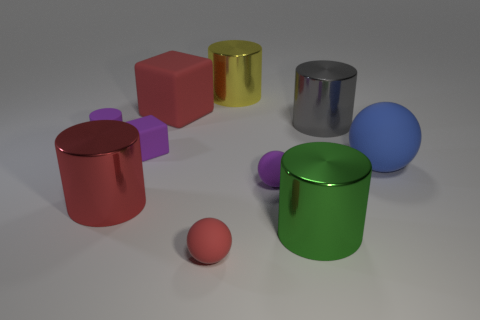What color is the big cube?
Give a very brief answer. Red. What number of other big matte spheres are the same color as the big matte ball?
Offer a terse response. 0. Are there any metallic cylinders right of the large yellow cylinder?
Your answer should be compact. Yes. Are there the same number of small matte cylinders in front of the green cylinder and tiny purple cylinders that are in front of the purple cylinder?
Offer a very short reply. Yes. There is a metallic thing to the left of the large yellow metallic thing; is its size the same as the green metallic cylinder on the right side of the large matte cube?
Offer a terse response. Yes. There is a large matte object that is right of the small thing that is in front of the metal cylinder in front of the red shiny object; what is its shape?
Give a very brief answer. Sphere. Are there any other things that are made of the same material as the large blue sphere?
Your response must be concise. Yes. There is another thing that is the same shape as the big red rubber thing; what size is it?
Your answer should be very brief. Small. The large thing that is both left of the small red sphere and behind the red shiny object is what color?
Ensure brevity in your answer.  Red. Is the material of the green cylinder the same as the sphere right of the purple matte sphere?
Provide a succinct answer. No. 